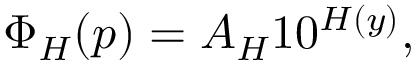<formula> <loc_0><loc_0><loc_500><loc_500>\Phi _ { H } ( p ) = A _ { H } 1 0 ^ { H ( y ) } ,</formula> 